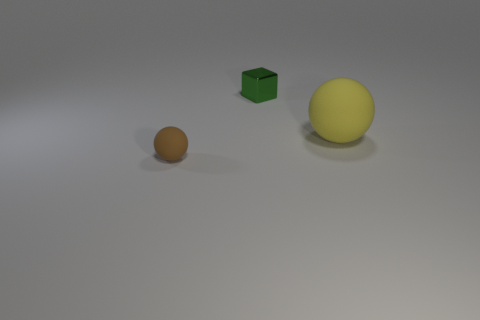Add 3 large blue metallic cubes. How many objects exist? 6 Subtract all blocks. How many objects are left? 2 Subtract all shiny blocks. Subtract all large yellow objects. How many objects are left? 1 Add 1 big yellow rubber balls. How many big yellow rubber balls are left? 2 Add 1 brown shiny cubes. How many brown shiny cubes exist? 1 Subtract 0 gray cylinders. How many objects are left? 3 